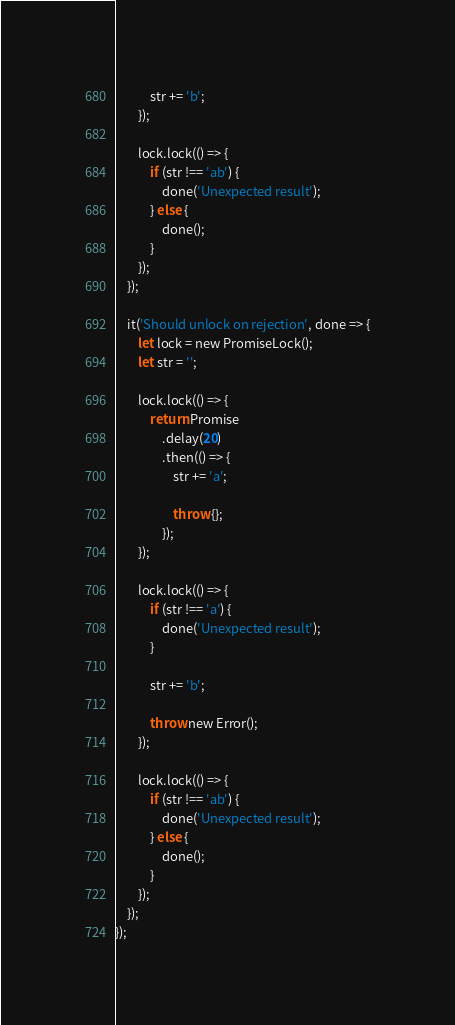<code> <loc_0><loc_0><loc_500><loc_500><_TypeScript_>
            str += 'b';
        });

        lock.lock(() => {
            if (str !== 'ab') {
                done('Unexpected result');
            } else {
                done();
            }
        });
    });

    it('Should unlock on rejection', done => {
        let lock = new PromiseLock();
        let str = '';

        lock.lock(() => {
            return Promise
                .delay(20)
                .then(() => {
                    str += 'a';

                    throw {};
                });
        });

        lock.lock(() => {
            if (str !== 'a') {
                done('Unexpected result');
            }

            str += 'b';

            throw new Error();
        });

        lock.lock(() => {
            if (str !== 'ab') {
                done('Unexpected result');
            } else {
                done();
            }
        });
    });
});
</code> 